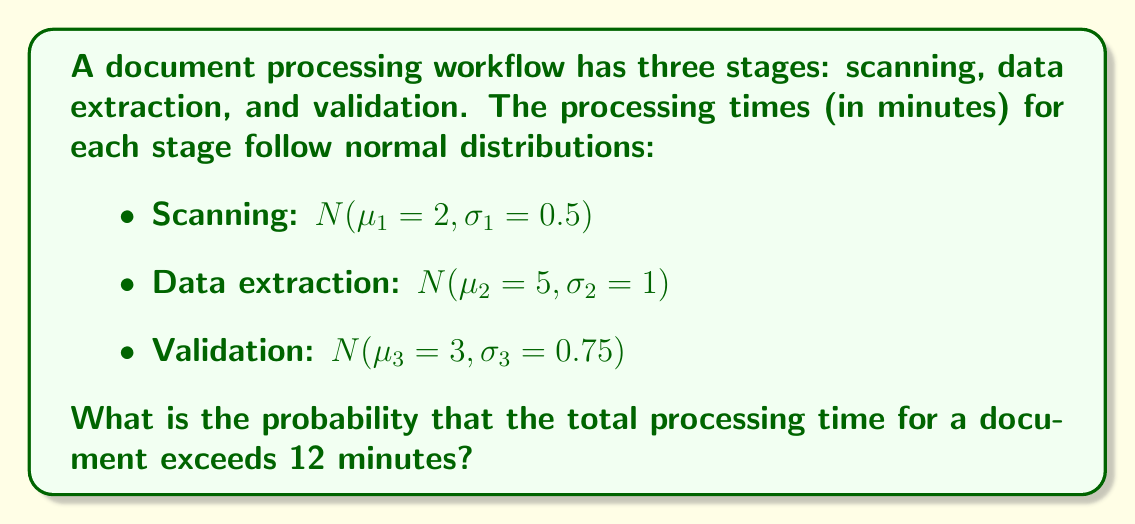Give your solution to this math problem. To solve this problem, we need to follow these steps:

1. Calculate the total mean processing time:
   $$\mu_{total} = \mu_1 + \mu_2 + \mu_3 = 2 + 5 + 3 = 10\text{ minutes}$$

2. Calculate the total variance of processing time:
   $$\sigma_{total}^2 = \sigma_1^2 + \sigma_2^2 + \sigma_3^2 = 0.5^2 + 1^2 + 0.75^2 = 1.8125$$

3. Calculate the standard deviation of total processing time:
   $$\sigma_{total} = \sqrt{1.8125} = 1.3463\text{ minutes}$$

4. The total processing time follows a normal distribution:
   $$N(\mu_{total} = 10, \sigma_{total} = 1.3463)$$

5. Calculate the z-score for 12 minutes:
   $$z = \frac{x - \mu_{total}}{\sigma_{total}} = \frac{12 - 10}{1.3463} = 1.4855$$

6. Find the probability using the standard normal distribution table or calculator:
   $$P(X > 12) = 1 - P(X \leq 12) = 1 - \Phi(1.4855) = 0.0687$$

Therefore, the probability that the total processing time exceeds 12 minutes is approximately 0.0687 or 6.87%.
Answer: 0.0687 